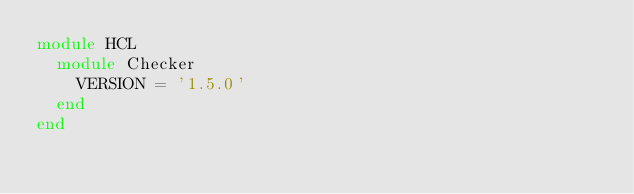<code> <loc_0><loc_0><loc_500><loc_500><_Ruby_>module HCL
  module Checker
    VERSION = '1.5.0'
  end
end
</code> 